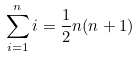<formula> <loc_0><loc_0><loc_500><loc_500>\sum _ { i = 1 } ^ { n } i = \frac { 1 } { 2 } n ( n + 1 )</formula> 